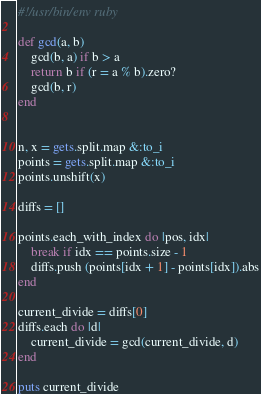Convert code to text. <code><loc_0><loc_0><loc_500><loc_500><_Ruby_>#!/usr/bin/env ruby

def gcd(a, b)
    gcd(b, a) if b > a
    return b if (r = a % b).zero?
    gcd(b, r)
end


n, x = gets.split.map &:to_i
points = gets.split.map &:to_i
points.unshift(x)

diffs = []

points.each_with_index do |pos, idx|
    break if idx == points.size - 1
    diffs.push (points[idx + 1] - points[idx]).abs
end

current_divide = diffs[0]
diffs.each do |d|
    current_divide = gcd(current_divide, d)
end

puts current_divide</code> 